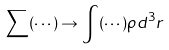Convert formula to latex. <formula><loc_0><loc_0><loc_500><loc_500>\sum ( \cdots ) \rightarrow \int ( \cdots ) \rho d ^ { 3 } r</formula> 